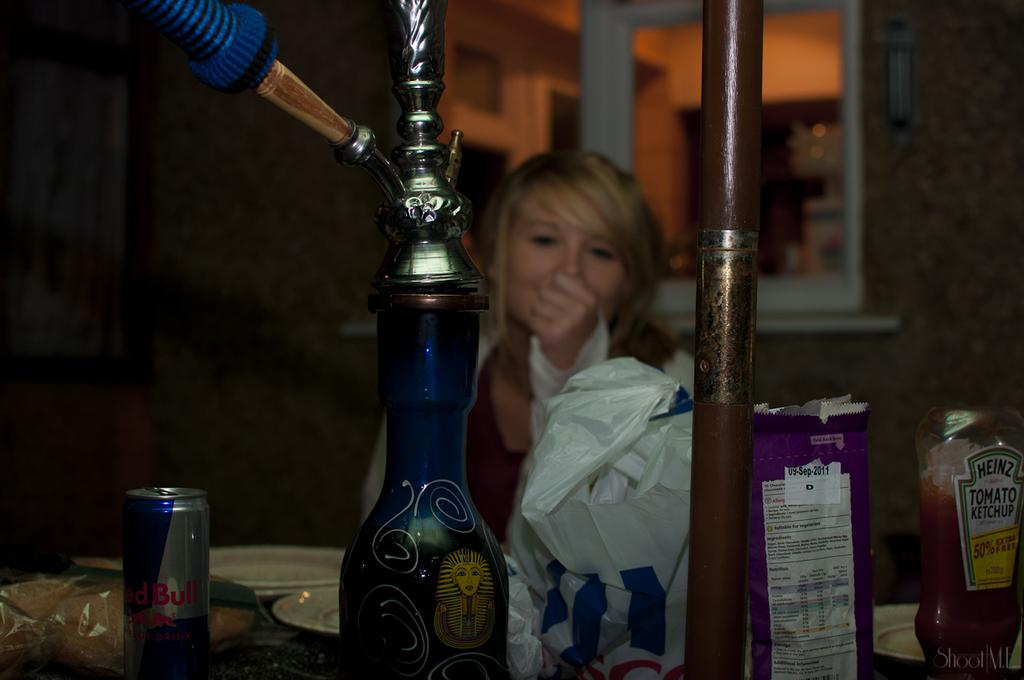Provide a one-sentence caption for the provided image. a table with a redbull, heinz ketchup and other items. 